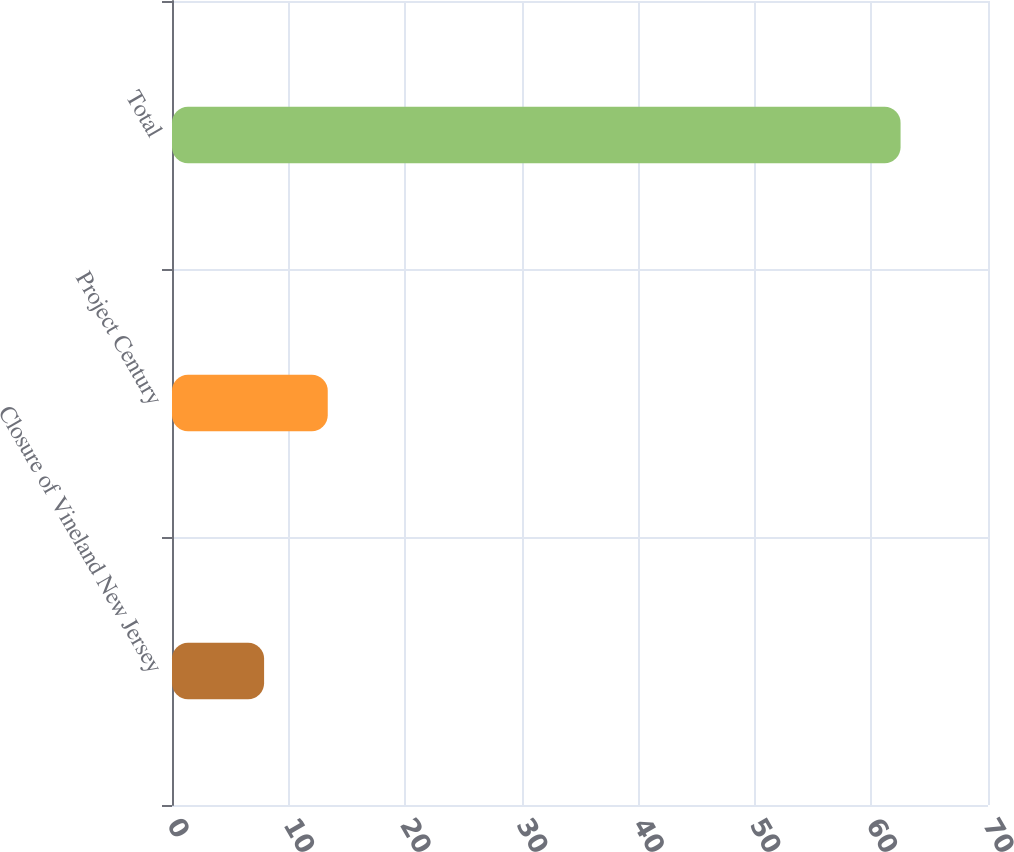Convert chart to OTSL. <chart><loc_0><loc_0><loc_500><loc_500><bar_chart><fcel>Closure of Vineland New Jersey<fcel>Project Century<fcel>Total<nl><fcel>7.9<fcel>13.36<fcel>62.5<nl></chart> 